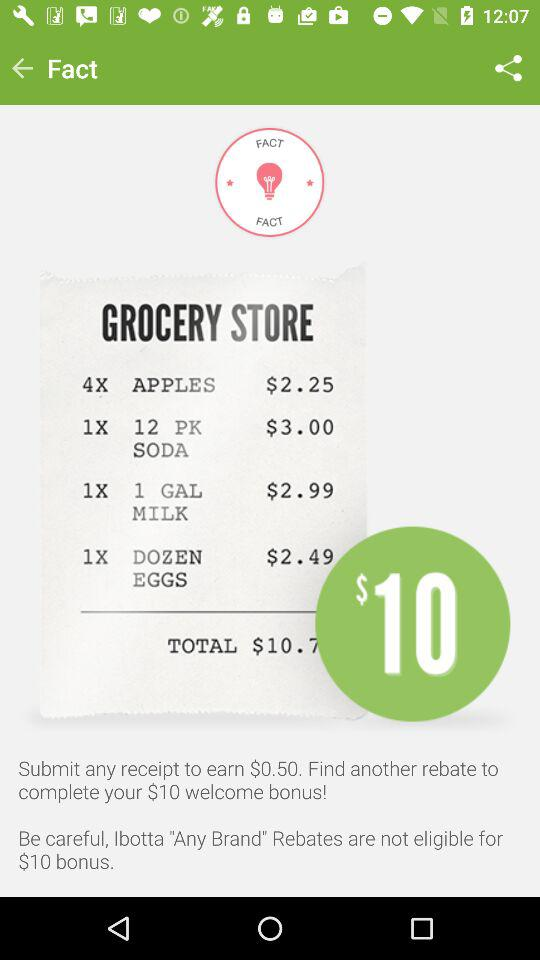What is the price of "Apples"? The price of "Apples" is $2.25. 